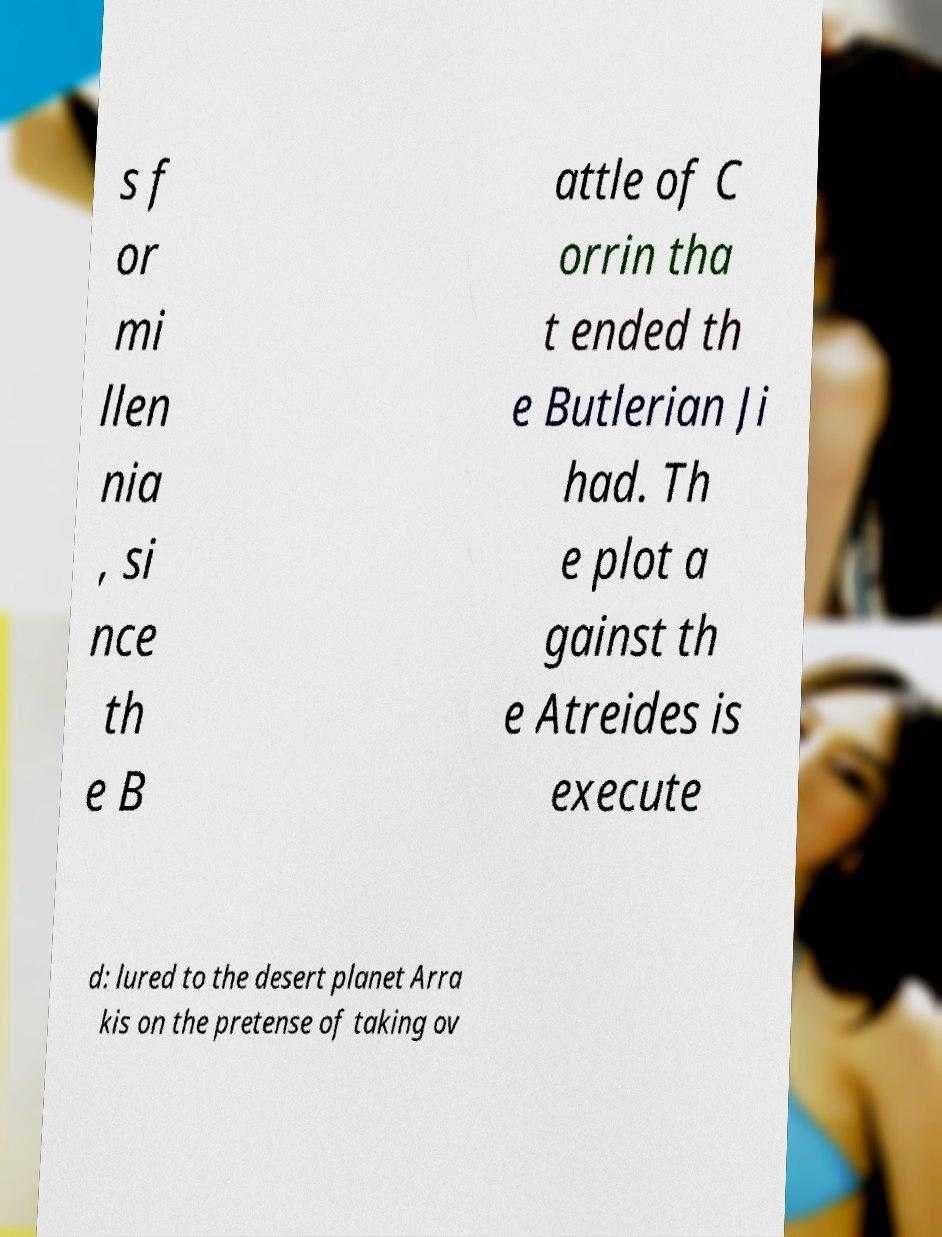Please identify and transcribe the text found in this image. s f or mi llen nia , si nce th e B attle of C orrin tha t ended th e Butlerian Ji had. Th e plot a gainst th e Atreides is execute d: lured to the desert planet Arra kis on the pretense of taking ov 